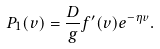Convert formula to latex. <formula><loc_0><loc_0><loc_500><loc_500>P _ { 1 } ( v ) = \frac { D } { g } f ^ { \prime } ( v ) e ^ { - \eta v } .</formula> 